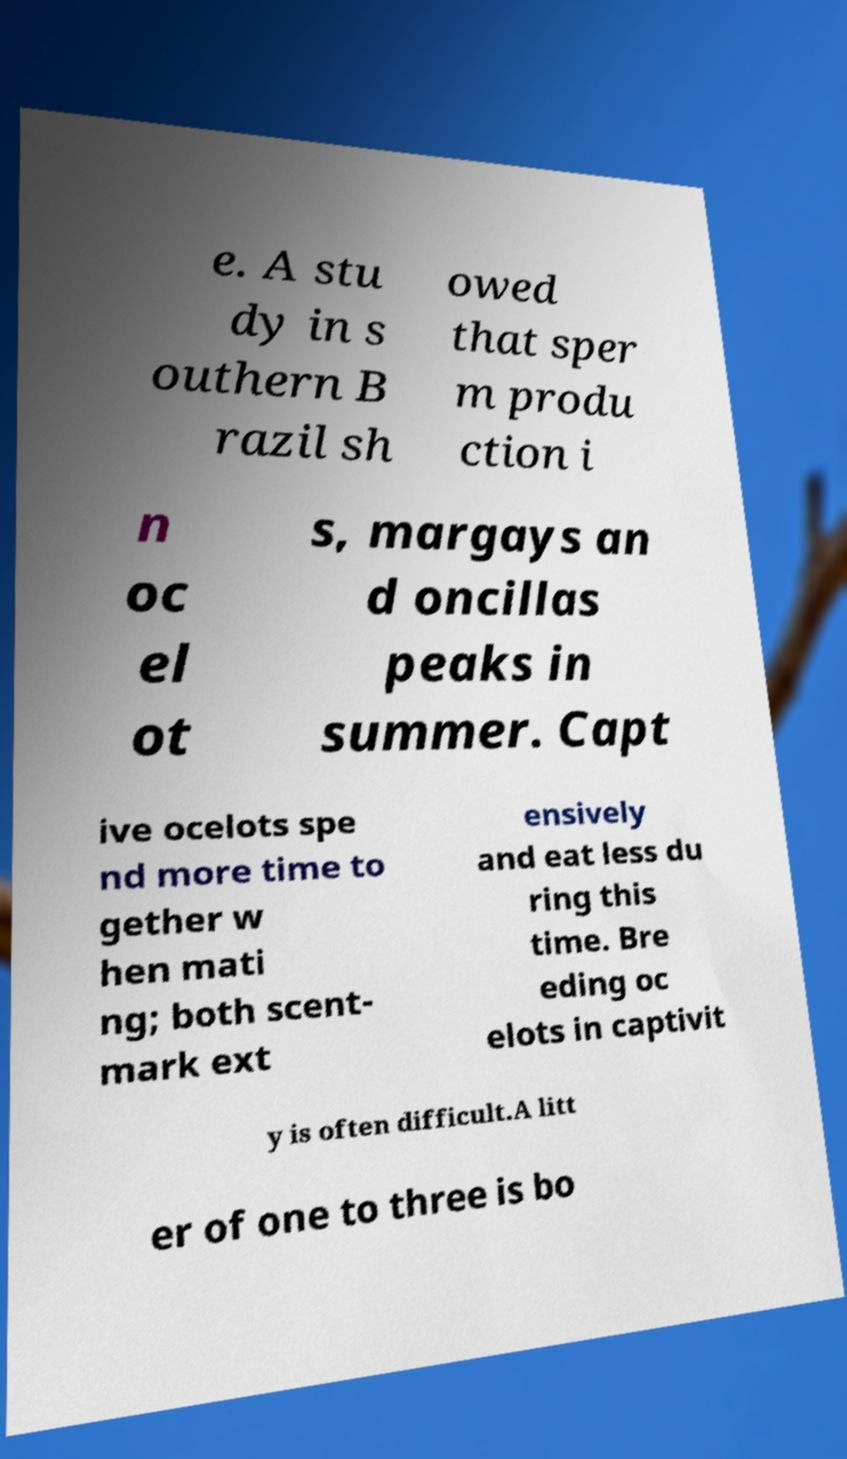What messages or text are displayed in this image? I need them in a readable, typed format. e. A stu dy in s outhern B razil sh owed that sper m produ ction i n oc el ot s, margays an d oncillas peaks in summer. Capt ive ocelots spe nd more time to gether w hen mati ng; both scent- mark ext ensively and eat less du ring this time. Bre eding oc elots in captivit y is often difficult.A litt er of one to three is bo 